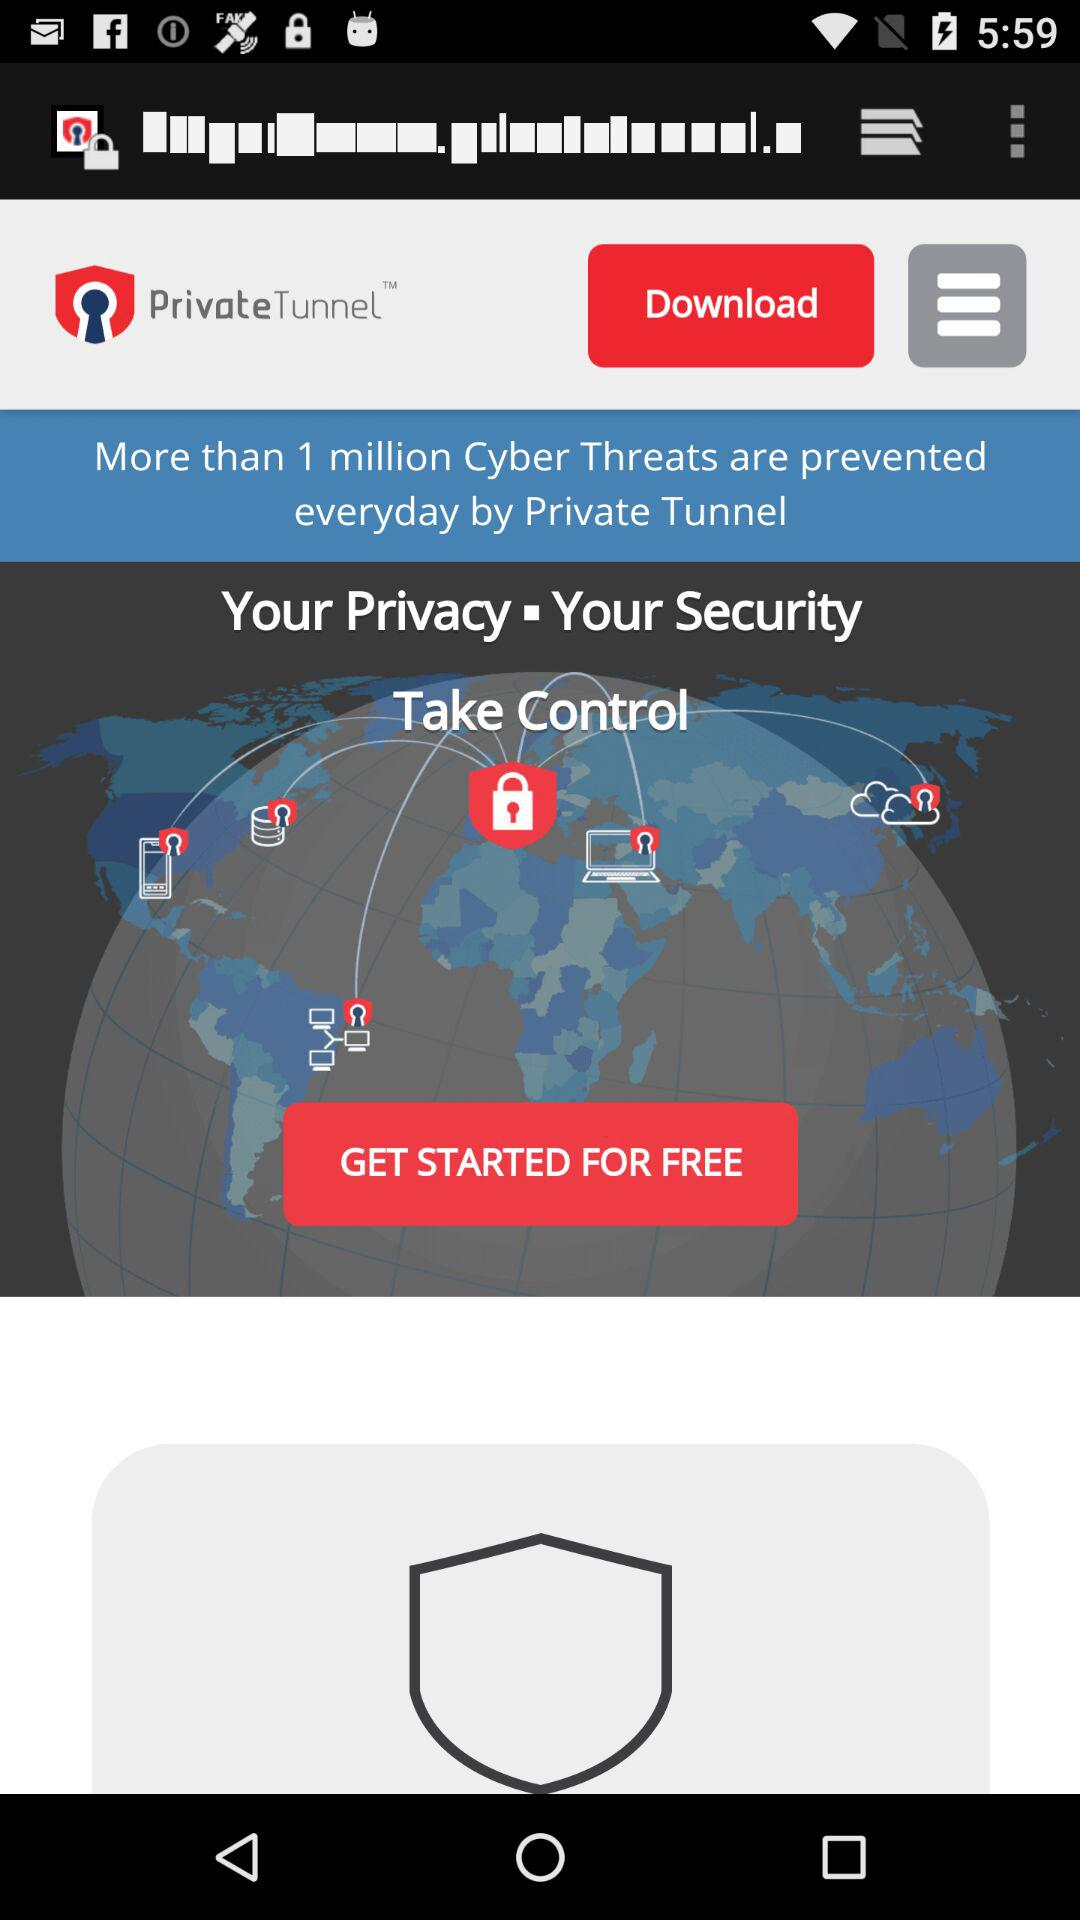How many "Cyber Threats" are prevented by Private Tunnel every day? The number of "Cyber Threats" that are prevented every day is more than 1 million. 